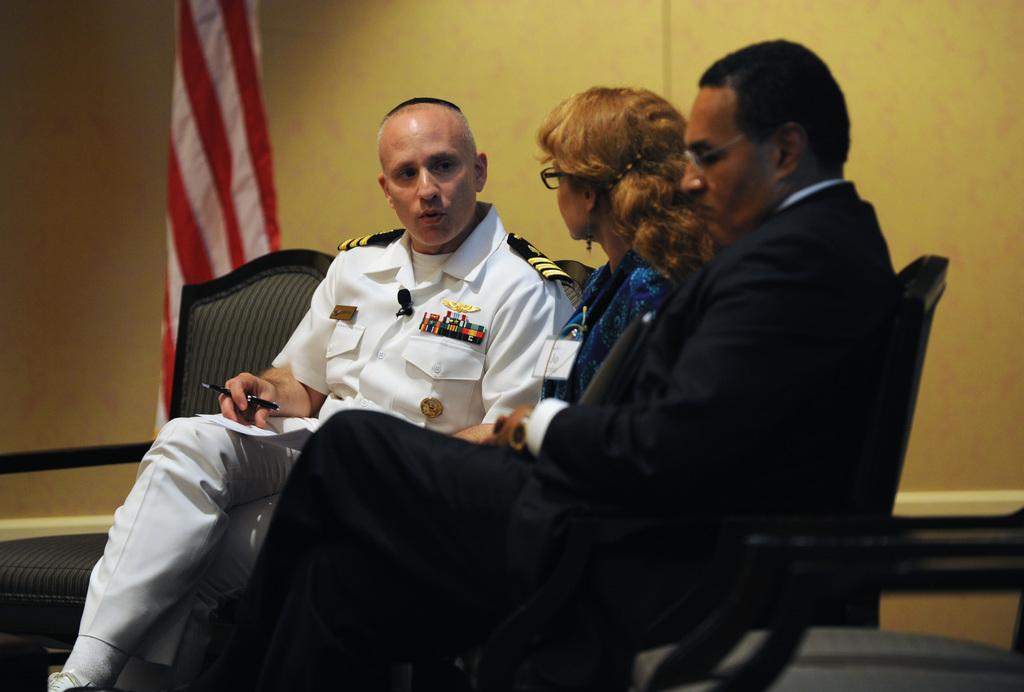What are the people in the image doing? The people in the image are sitting on chairs. What can be seen in the background of the image? There is a flag and a wall in the background of the image. What type of orange is being used to create the effect in the image? There is no orange or any effect present in the image; it features people sitting on chairs with a flag and a wall in the background. 